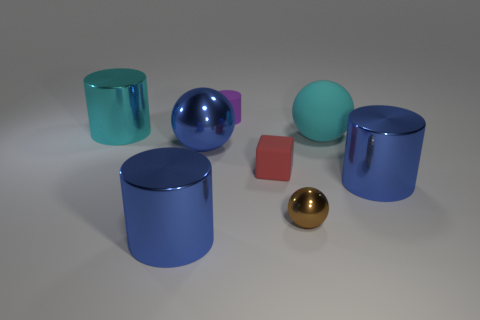Are there any repeating patterns or shapes in the image? Yes, there is a repeating pattern in the image consisting of cylindrical shapes. There are multiple objects with this base shape—some are oriented vertically, while others are horizontal. These repeating cylindrical forms create a sense of rhythm and unity within the composition. 